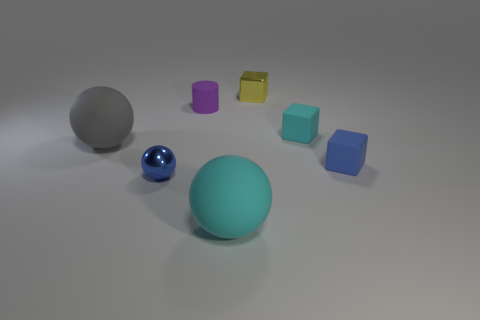Add 3 big gray things. How many objects exist? 10 Subtract all blocks. How many objects are left? 4 Add 7 cyan rubber objects. How many cyan rubber objects are left? 9 Add 6 blue rubber blocks. How many blue rubber blocks exist? 7 Subtract 0 gray blocks. How many objects are left? 7 Subtract all cyan matte things. Subtract all big cylinders. How many objects are left? 5 